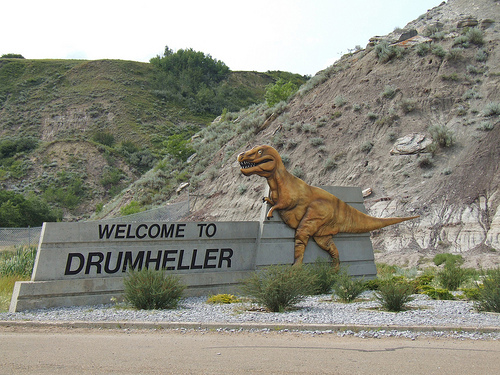<image>
Is there a plant to the left of the wall? No. The plant is not to the left of the wall. From this viewpoint, they have a different horizontal relationship. 